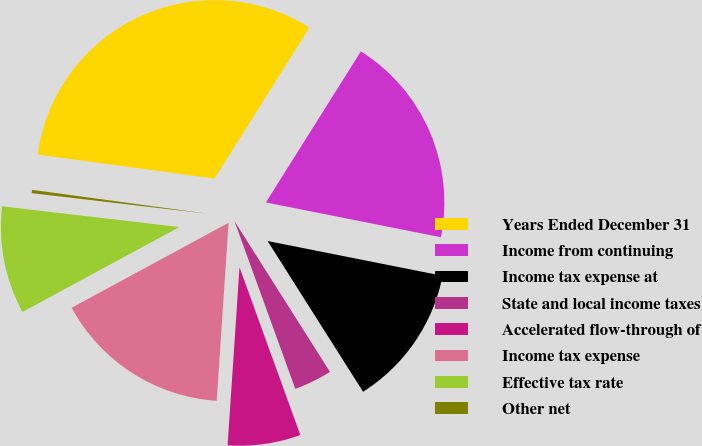<chart> <loc_0><loc_0><loc_500><loc_500><pie_chart><fcel>Years Ended December 31<fcel>Income from continuing<fcel>Income tax expense at<fcel>State and local income taxes<fcel>Accelerated flow-through of<fcel>Income tax expense<fcel>Effective tax rate<fcel>Other net<nl><fcel>31.78%<fcel>19.19%<fcel>12.89%<fcel>3.45%<fcel>6.6%<fcel>16.04%<fcel>9.75%<fcel>0.3%<nl></chart> 